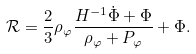Convert formula to latex. <formula><loc_0><loc_0><loc_500><loc_500>\mathcal { R } = \frac { 2 } { 3 } \rho _ { \varphi } \frac { H ^ { - 1 } \dot { \Phi } + \Phi } { \rho _ { \varphi } + P _ { \varphi } } + \Phi .</formula> 